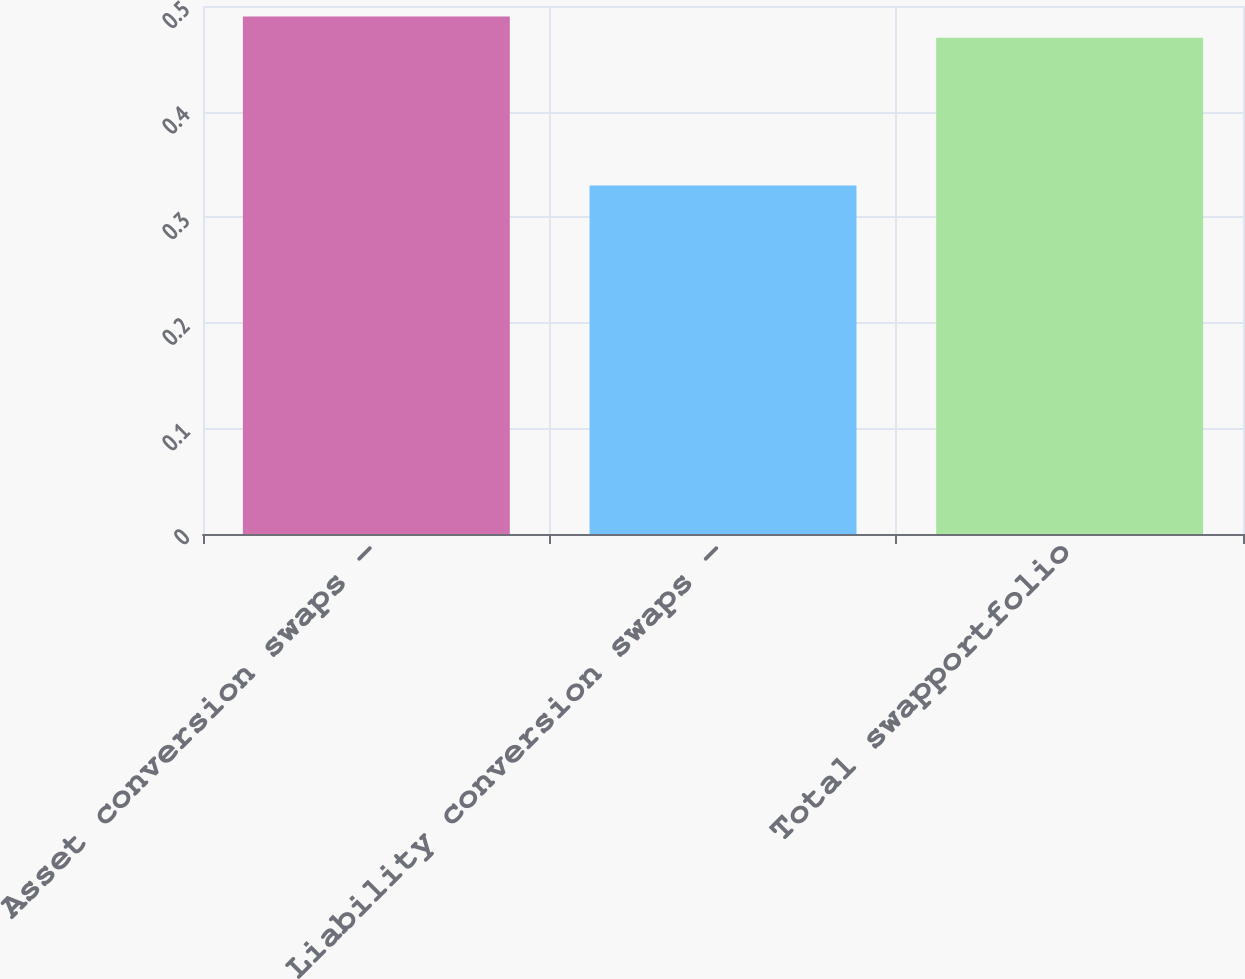<chart> <loc_0><loc_0><loc_500><loc_500><bar_chart><fcel>Asset conversion swaps -<fcel>Liability conversion swaps -<fcel>Total swapportfolio<nl><fcel>0.49<fcel>0.33<fcel>0.47<nl></chart> 